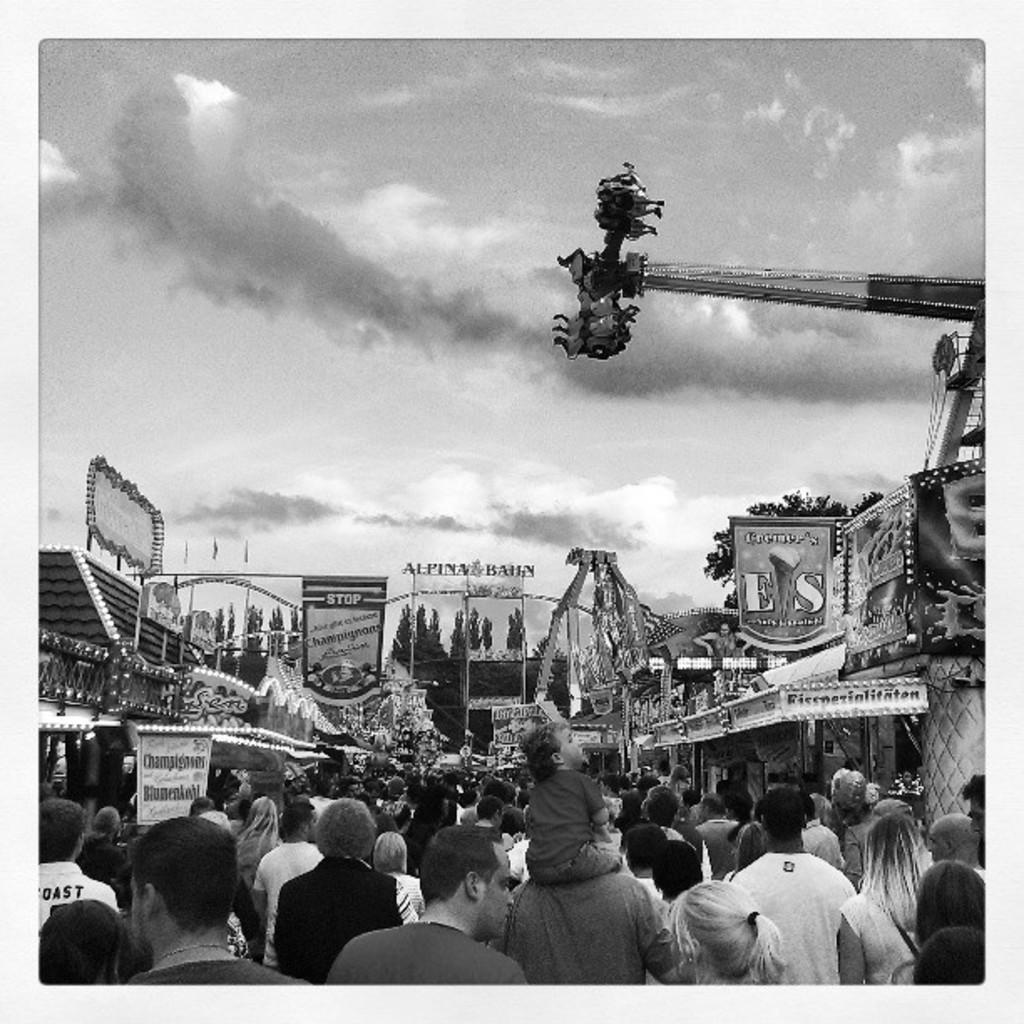What is the color scheme of the image? The image is black and white. Can you describe the subjects in the image? There is a group of people, boards, trees, houses, and a crane in the image. What can be seen in the background of the image? The sky with clouds is visible in the background of the image. What type of button is being used to control the crane in the image? There is no button present in the image, and the crane's operation is not depicted. Is there a joke being told by the group of people in the image? There is no indication of a joke being told in the image; the group of people is not engaged in any specific activity. 